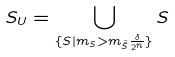<formula> <loc_0><loc_0><loc_500><loc_500>S _ { U } = \bigcup _ { \{ S | m _ { S } > m _ { \hat { \hat { S } } } \frac { \delta } { 2 ^ { n } } \} } S</formula> 